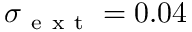<formula> <loc_0><loc_0><loc_500><loc_500>\sigma _ { e x t } = 0 . 0 4</formula> 